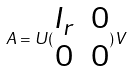<formula> <loc_0><loc_0><loc_500><loc_500>A = U ( \begin{matrix} I _ { r } & 0 \\ 0 & 0 \end{matrix} ) V</formula> 